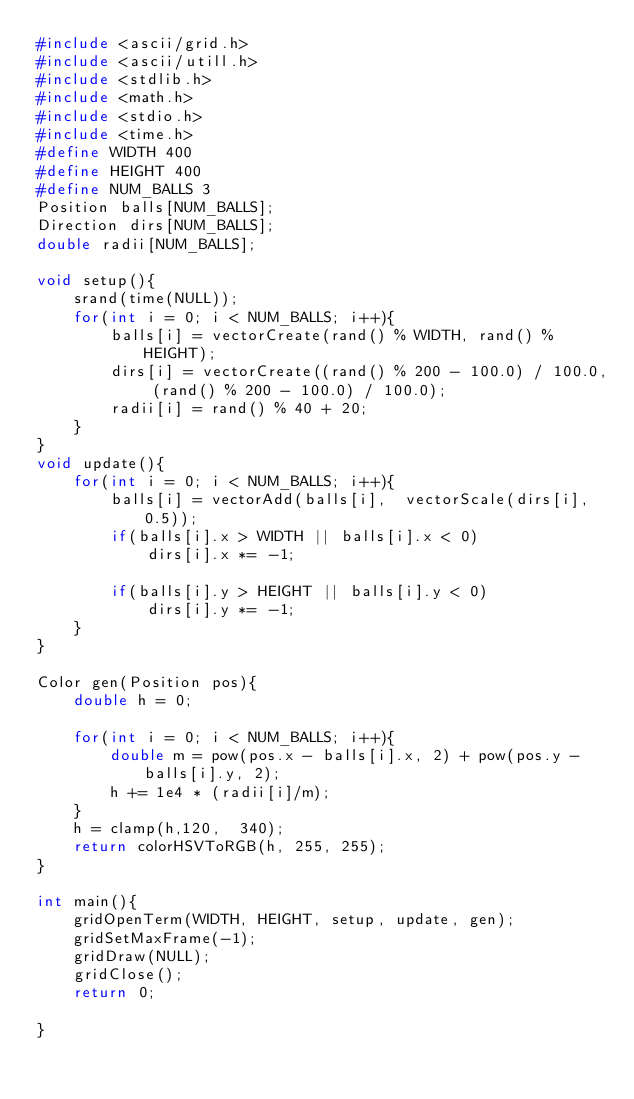<code> <loc_0><loc_0><loc_500><loc_500><_C_>#include <ascii/grid.h>
#include <ascii/utill.h>
#include <stdlib.h>
#include <math.h>
#include <stdio.h>
#include <time.h>
#define WIDTH 400
#define HEIGHT 400
#define NUM_BALLS 3
Position balls[NUM_BALLS];
Direction dirs[NUM_BALLS];
double radii[NUM_BALLS];

void setup(){
	srand(time(NULL));
	for(int i = 0; i < NUM_BALLS; i++){
		balls[i] = vectorCreate(rand() % WIDTH, rand() % HEIGHT); 
		dirs[i] = vectorCreate((rand() % 200 - 100.0) / 100.0, (rand() % 200 - 100.0) / 100.0); 
		radii[i] = rand() % 40 + 20;
	}
}
void update(){
	for(int i = 0; i < NUM_BALLS; i++){
		balls[i] = vectorAdd(balls[i],  vectorScale(dirs[i], 0.5));
		if(balls[i].x > WIDTH || balls[i].x < 0)
			dirs[i].x *= -1;

		if(balls[i].y > HEIGHT || balls[i].y < 0)
			dirs[i].y *= -1;
	}
}

Color gen(Position pos){
	double h = 0;
	
	for(int i = 0; i < NUM_BALLS; i++){
		double m = pow(pos.x - balls[i].x, 2) + pow(pos.y - balls[i].y, 2);
		h += 1e4 * (radii[i]/m);
	}
	h = clamp(h,120,  340);
	return colorHSVToRGB(h, 255, 255);
}

int main(){
	gridOpenTerm(WIDTH, HEIGHT, setup, update, gen); 
	gridSetMaxFrame(-1);
	gridDraw(NULL);
	gridClose();
	return 0;

}
</code> 